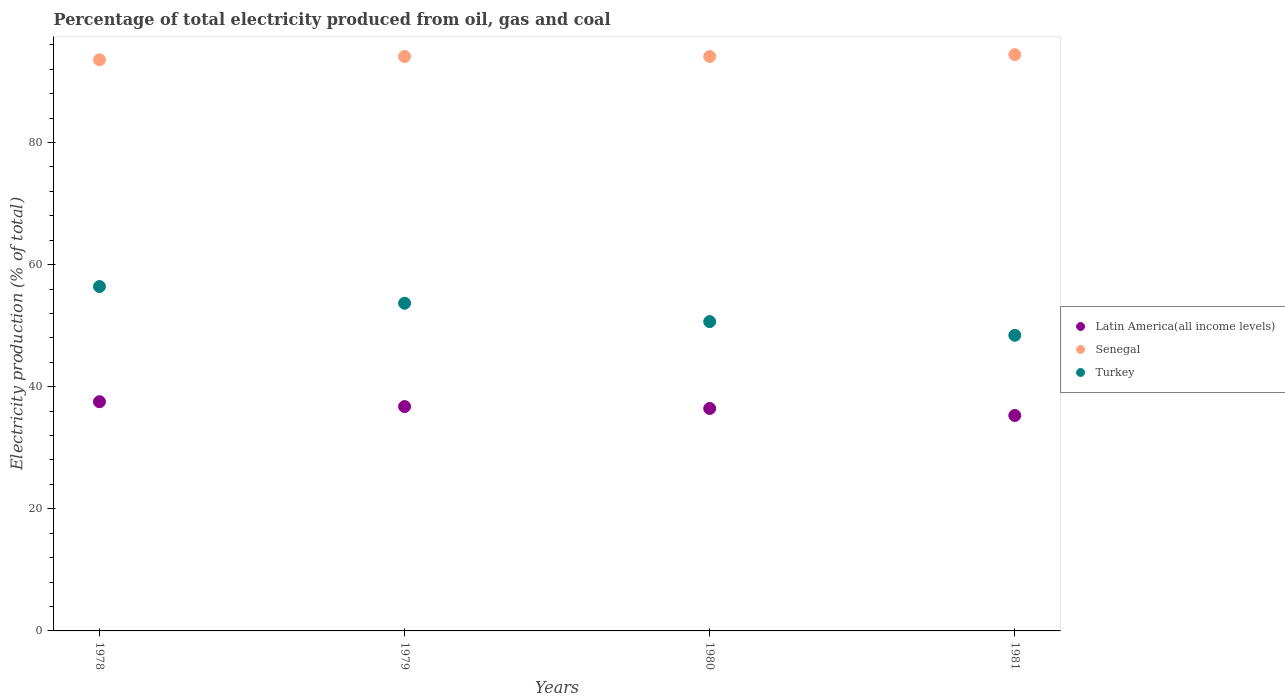Is the number of dotlines equal to the number of legend labels?
Provide a short and direct response. Yes. What is the electricity production in in Senegal in 1981?
Offer a terse response. 94.39. Across all years, what is the maximum electricity production in in Latin America(all income levels)?
Provide a succinct answer. 37.54. Across all years, what is the minimum electricity production in in Turkey?
Provide a succinct answer. 48.42. In which year was the electricity production in in Senegal maximum?
Your answer should be compact. 1981. In which year was the electricity production in in Senegal minimum?
Your response must be concise. 1978. What is the total electricity production in in Latin America(all income levels) in the graph?
Offer a terse response. 146.01. What is the difference between the electricity production in in Latin America(all income levels) in 1980 and that in 1981?
Give a very brief answer. 1.15. What is the difference between the electricity production in in Latin America(all income levels) in 1981 and the electricity production in in Senegal in 1978?
Your answer should be very brief. -58.26. What is the average electricity production in in Senegal per year?
Give a very brief answer. 94.03. In the year 1978, what is the difference between the electricity production in in Senegal and electricity production in in Turkey?
Your answer should be compact. 37.15. In how many years, is the electricity production in in Latin America(all income levels) greater than 16 %?
Ensure brevity in your answer.  4. What is the ratio of the electricity production in in Latin America(all income levels) in 1980 to that in 1981?
Provide a succinct answer. 1.03. Is the electricity production in in Turkey in 1978 less than that in 1981?
Make the answer very short. No. What is the difference between the highest and the second highest electricity production in in Latin America(all income levels)?
Provide a succinct answer. 0.79. What is the difference between the highest and the lowest electricity production in in Turkey?
Keep it short and to the point. 7.98. In how many years, is the electricity production in in Senegal greater than the average electricity production in in Senegal taken over all years?
Your response must be concise. 3. Is the sum of the electricity production in in Latin America(all income levels) in 1979 and 1980 greater than the maximum electricity production in in Senegal across all years?
Offer a very short reply. No. Is it the case that in every year, the sum of the electricity production in in Latin America(all income levels) and electricity production in in Senegal  is greater than the electricity production in in Turkey?
Keep it short and to the point. Yes. Is the electricity production in in Latin America(all income levels) strictly less than the electricity production in in Senegal over the years?
Keep it short and to the point. Yes. What is the title of the graph?
Your response must be concise. Percentage of total electricity produced from oil, gas and coal. Does "United Arab Emirates" appear as one of the legend labels in the graph?
Provide a succinct answer. No. What is the label or title of the Y-axis?
Give a very brief answer. Electricity production (% of total). What is the Electricity production (% of total) in Latin America(all income levels) in 1978?
Offer a terse response. 37.54. What is the Electricity production (% of total) of Senegal in 1978?
Provide a short and direct response. 93.55. What is the Electricity production (% of total) of Turkey in 1978?
Your answer should be very brief. 56.4. What is the Electricity production (% of total) in Latin America(all income levels) in 1979?
Make the answer very short. 36.75. What is the Electricity production (% of total) of Senegal in 1979?
Ensure brevity in your answer.  94.08. What is the Electricity production (% of total) in Turkey in 1979?
Your response must be concise. 53.67. What is the Electricity production (% of total) of Latin America(all income levels) in 1980?
Give a very brief answer. 36.44. What is the Electricity production (% of total) of Senegal in 1980?
Offer a terse response. 94.08. What is the Electricity production (% of total) of Turkey in 1980?
Provide a succinct answer. 50.66. What is the Electricity production (% of total) of Latin America(all income levels) in 1981?
Give a very brief answer. 35.29. What is the Electricity production (% of total) in Senegal in 1981?
Provide a succinct answer. 94.39. What is the Electricity production (% of total) in Turkey in 1981?
Offer a terse response. 48.42. Across all years, what is the maximum Electricity production (% of total) in Latin America(all income levels)?
Your response must be concise. 37.54. Across all years, what is the maximum Electricity production (% of total) of Senegal?
Provide a short and direct response. 94.39. Across all years, what is the maximum Electricity production (% of total) in Turkey?
Your answer should be compact. 56.4. Across all years, what is the minimum Electricity production (% of total) of Latin America(all income levels)?
Keep it short and to the point. 35.29. Across all years, what is the minimum Electricity production (% of total) in Senegal?
Offer a terse response. 93.55. Across all years, what is the minimum Electricity production (% of total) in Turkey?
Give a very brief answer. 48.42. What is the total Electricity production (% of total) in Latin America(all income levels) in the graph?
Your answer should be compact. 146.01. What is the total Electricity production (% of total) in Senegal in the graph?
Your response must be concise. 376.1. What is the total Electricity production (% of total) of Turkey in the graph?
Offer a very short reply. 209.16. What is the difference between the Electricity production (% of total) of Latin America(all income levels) in 1978 and that in 1979?
Make the answer very short. 0.79. What is the difference between the Electricity production (% of total) in Senegal in 1978 and that in 1979?
Provide a short and direct response. -0.53. What is the difference between the Electricity production (% of total) in Turkey in 1978 and that in 1979?
Your answer should be compact. 2.73. What is the difference between the Electricity production (% of total) in Latin America(all income levels) in 1978 and that in 1980?
Give a very brief answer. 1.11. What is the difference between the Electricity production (% of total) of Senegal in 1978 and that in 1980?
Provide a short and direct response. -0.53. What is the difference between the Electricity production (% of total) in Turkey in 1978 and that in 1980?
Provide a succinct answer. 5.74. What is the difference between the Electricity production (% of total) of Latin America(all income levels) in 1978 and that in 1981?
Your answer should be very brief. 2.26. What is the difference between the Electricity production (% of total) of Senegal in 1978 and that in 1981?
Make the answer very short. -0.84. What is the difference between the Electricity production (% of total) in Turkey in 1978 and that in 1981?
Ensure brevity in your answer.  7.98. What is the difference between the Electricity production (% of total) of Latin America(all income levels) in 1979 and that in 1980?
Your answer should be compact. 0.31. What is the difference between the Electricity production (% of total) in Turkey in 1979 and that in 1980?
Provide a succinct answer. 3.01. What is the difference between the Electricity production (% of total) of Latin America(all income levels) in 1979 and that in 1981?
Offer a terse response. 1.46. What is the difference between the Electricity production (% of total) of Senegal in 1979 and that in 1981?
Your answer should be compact. -0.31. What is the difference between the Electricity production (% of total) in Turkey in 1979 and that in 1981?
Your answer should be very brief. 5.25. What is the difference between the Electricity production (% of total) in Latin America(all income levels) in 1980 and that in 1981?
Your response must be concise. 1.15. What is the difference between the Electricity production (% of total) of Senegal in 1980 and that in 1981?
Keep it short and to the point. -0.31. What is the difference between the Electricity production (% of total) of Turkey in 1980 and that in 1981?
Your answer should be very brief. 2.24. What is the difference between the Electricity production (% of total) of Latin America(all income levels) in 1978 and the Electricity production (% of total) of Senegal in 1979?
Your response must be concise. -56.54. What is the difference between the Electricity production (% of total) in Latin America(all income levels) in 1978 and the Electricity production (% of total) in Turkey in 1979?
Keep it short and to the point. -16.13. What is the difference between the Electricity production (% of total) of Senegal in 1978 and the Electricity production (% of total) of Turkey in 1979?
Provide a short and direct response. 39.88. What is the difference between the Electricity production (% of total) in Latin America(all income levels) in 1978 and the Electricity production (% of total) in Senegal in 1980?
Provide a succinct answer. -56.54. What is the difference between the Electricity production (% of total) of Latin America(all income levels) in 1978 and the Electricity production (% of total) of Turkey in 1980?
Your response must be concise. -13.12. What is the difference between the Electricity production (% of total) of Senegal in 1978 and the Electricity production (% of total) of Turkey in 1980?
Offer a very short reply. 42.89. What is the difference between the Electricity production (% of total) of Latin America(all income levels) in 1978 and the Electricity production (% of total) of Senegal in 1981?
Keep it short and to the point. -56.85. What is the difference between the Electricity production (% of total) in Latin America(all income levels) in 1978 and the Electricity production (% of total) in Turkey in 1981?
Offer a very short reply. -10.88. What is the difference between the Electricity production (% of total) of Senegal in 1978 and the Electricity production (% of total) of Turkey in 1981?
Ensure brevity in your answer.  45.13. What is the difference between the Electricity production (% of total) in Latin America(all income levels) in 1979 and the Electricity production (% of total) in Senegal in 1980?
Your response must be concise. -57.33. What is the difference between the Electricity production (% of total) in Latin America(all income levels) in 1979 and the Electricity production (% of total) in Turkey in 1980?
Keep it short and to the point. -13.91. What is the difference between the Electricity production (% of total) in Senegal in 1979 and the Electricity production (% of total) in Turkey in 1980?
Your answer should be compact. 43.42. What is the difference between the Electricity production (% of total) in Latin America(all income levels) in 1979 and the Electricity production (% of total) in Senegal in 1981?
Provide a succinct answer. -57.64. What is the difference between the Electricity production (% of total) of Latin America(all income levels) in 1979 and the Electricity production (% of total) of Turkey in 1981?
Give a very brief answer. -11.67. What is the difference between the Electricity production (% of total) of Senegal in 1979 and the Electricity production (% of total) of Turkey in 1981?
Keep it short and to the point. 45.66. What is the difference between the Electricity production (% of total) of Latin America(all income levels) in 1980 and the Electricity production (% of total) of Senegal in 1981?
Your answer should be very brief. -57.95. What is the difference between the Electricity production (% of total) of Latin America(all income levels) in 1980 and the Electricity production (% of total) of Turkey in 1981?
Offer a very short reply. -11.99. What is the difference between the Electricity production (% of total) in Senegal in 1980 and the Electricity production (% of total) in Turkey in 1981?
Give a very brief answer. 45.66. What is the average Electricity production (% of total) in Latin America(all income levels) per year?
Provide a succinct answer. 36.5. What is the average Electricity production (% of total) in Senegal per year?
Provide a succinct answer. 94.03. What is the average Electricity production (% of total) in Turkey per year?
Offer a terse response. 52.29. In the year 1978, what is the difference between the Electricity production (% of total) in Latin America(all income levels) and Electricity production (% of total) in Senegal?
Ensure brevity in your answer.  -56.01. In the year 1978, what is the difference between the Electricity production (% of total) in Latin America(all income levels) and Electricity production (% of total) in Turkey?
Give a very brief answer. -18.86. In the year 1978, what is the difference between the Electricity production (% of total) of Senegal and Electricity production (% of total) of Turkey?
Provide a succinct answer. 37.15. In the year 1979, what is the difference between the Electricity production (% of total) in Latin America(all income levels) and Electricity production (% of total) in Senegal?
Keep it short and to the point. -57.33. In the year 1979, what is the difference between the Electricity production (% of total) of Latin America(all income levels) and Electricity production (% of total) of Turkey?
Provide a succinct answer. -16.92. In the year 1979, what is the difference between the Electricity production (% of total) of Senegal and Electricity production (% of total) of Turkey?
Offer a very short reply. 40.41. In the year 1980, what is the difference between the Electricity production (% of total) of Latin America(all income levels) and Electricity production (% of total) of Senegal?
Give a very brief answer. -57.65. In the year 1980, what is the difference between the Electricity production (% of total) in Latin America(all income levels) and Electricity production (% of total) in Turkey?
Keep it short and to the point. -14.22. In the year 1980, what is the difference between the Electricity production (% of total) of Senegal and Electricity production (% of total) of Turkey?
Your response must be concise. 43.42. In the year 1981, what is the difference between the Electricity production (% of total) of Latin America(all income levels) and Electricity production (% of total) of Senegal?
Give a very brief answer. -59.1. In the year 1981, what is the difference between the Electricity production (% of total) in Latin America(all income levels) and Electricity production (% of total) in Turkey?
Provide a short and direct response. -13.14. In the year 1981, what is the difference between the Electricity production (% of total) of Senegal and Electricity production (% of total) of Turkey?
Provide a succinct answer. 45.97. What is the ratio of the Electricity production (% of total) of Latin America(all income levels) in 1978 to that in 1979?
Your answer should be very brief. 1.02. What is the ratio of the Electricity production (% of total) of Senegal in 1978 to that in 1979?
Give a very brief answer. 0.99. What is the ratio of the Electricity production (% of total) in Turkey in 1978 to that in 1979?
Provide a succinct answer. 1.05. What is the ratio of the Electricity production (% of total) of Latin America(all income levels) in 1978 to that in 1980?
Offer a terse response. 1.03. What is the ratio of the Electricity production (% of total) in Turkey in 1978 to that in 1980?
Give a very brief answer. 1.11. What is the ratio of the Electricity production (% of total) in Latin America(all income levels) in 1978 to that in 1981?
Make the answer very short. 1.06. What is the ratio of the Electricity production (% of total) in Turkey in 1978 to that in 1981?
Provide a succinct answer. 1.16. What is the ratio of the Electricity production (% of total) of Latin America(all income levels) in 1979 to that in 1980?
Provide a succinct answer. 1.01. What is the ratio of the Electricity production (% of total) of Turkey in 1979 to that in 1980?
Your answer should be very brief. 1.06. What is the ratio of the Electricity production (% of total) of Latin America(all income levels) in 1979 to that in 1981?
Offer a very short reply. 1.04. What is the ratio of the Electricity production (% of total) of Senegal in 1979 to that in 1981?
Your answer should be very brief. 1. What is the ratio of the Electricity production (% of total) of Turkey in 1979 to that in 1981?
Ensure brevity in your answer.  1.11. What is the ratio of the Electricity production (% of total) of Latin America(all income levels) in 1980 to that in 1981?
Your answer should be very brief. 1.03. What is the ratio of the Electricity production (% of total) in Turkey in 1980 to that in 1981?
Give a very brief answer. 1.05. What is the difference between the highest and the second highest Electricity production (% of total) of Latin America(all income levels)?
Ensure brevity in your answer.  0.79. What is the difference between the highest and the second highest Electricity production (% of total) in Senegal?
Make the answer very short. 0.31. What is the difference between the highest and the second highest Electricity production (% of total) in Turkey?
Your answer should be very brief. 2.73. What is the difference between the highest and the lowest Electricity production (% of total) in Latin America(all income levels)?
Provide a short and direct response. 2.26. What is the difference between the highest and the lowest Electricity production (% of total) in Senegal?
Provide a succinct answer. 0.84. What is the difference between the highest and the lowest Electricity production (% of total) in Turkey?
Your answer should be compact. 7.98. 